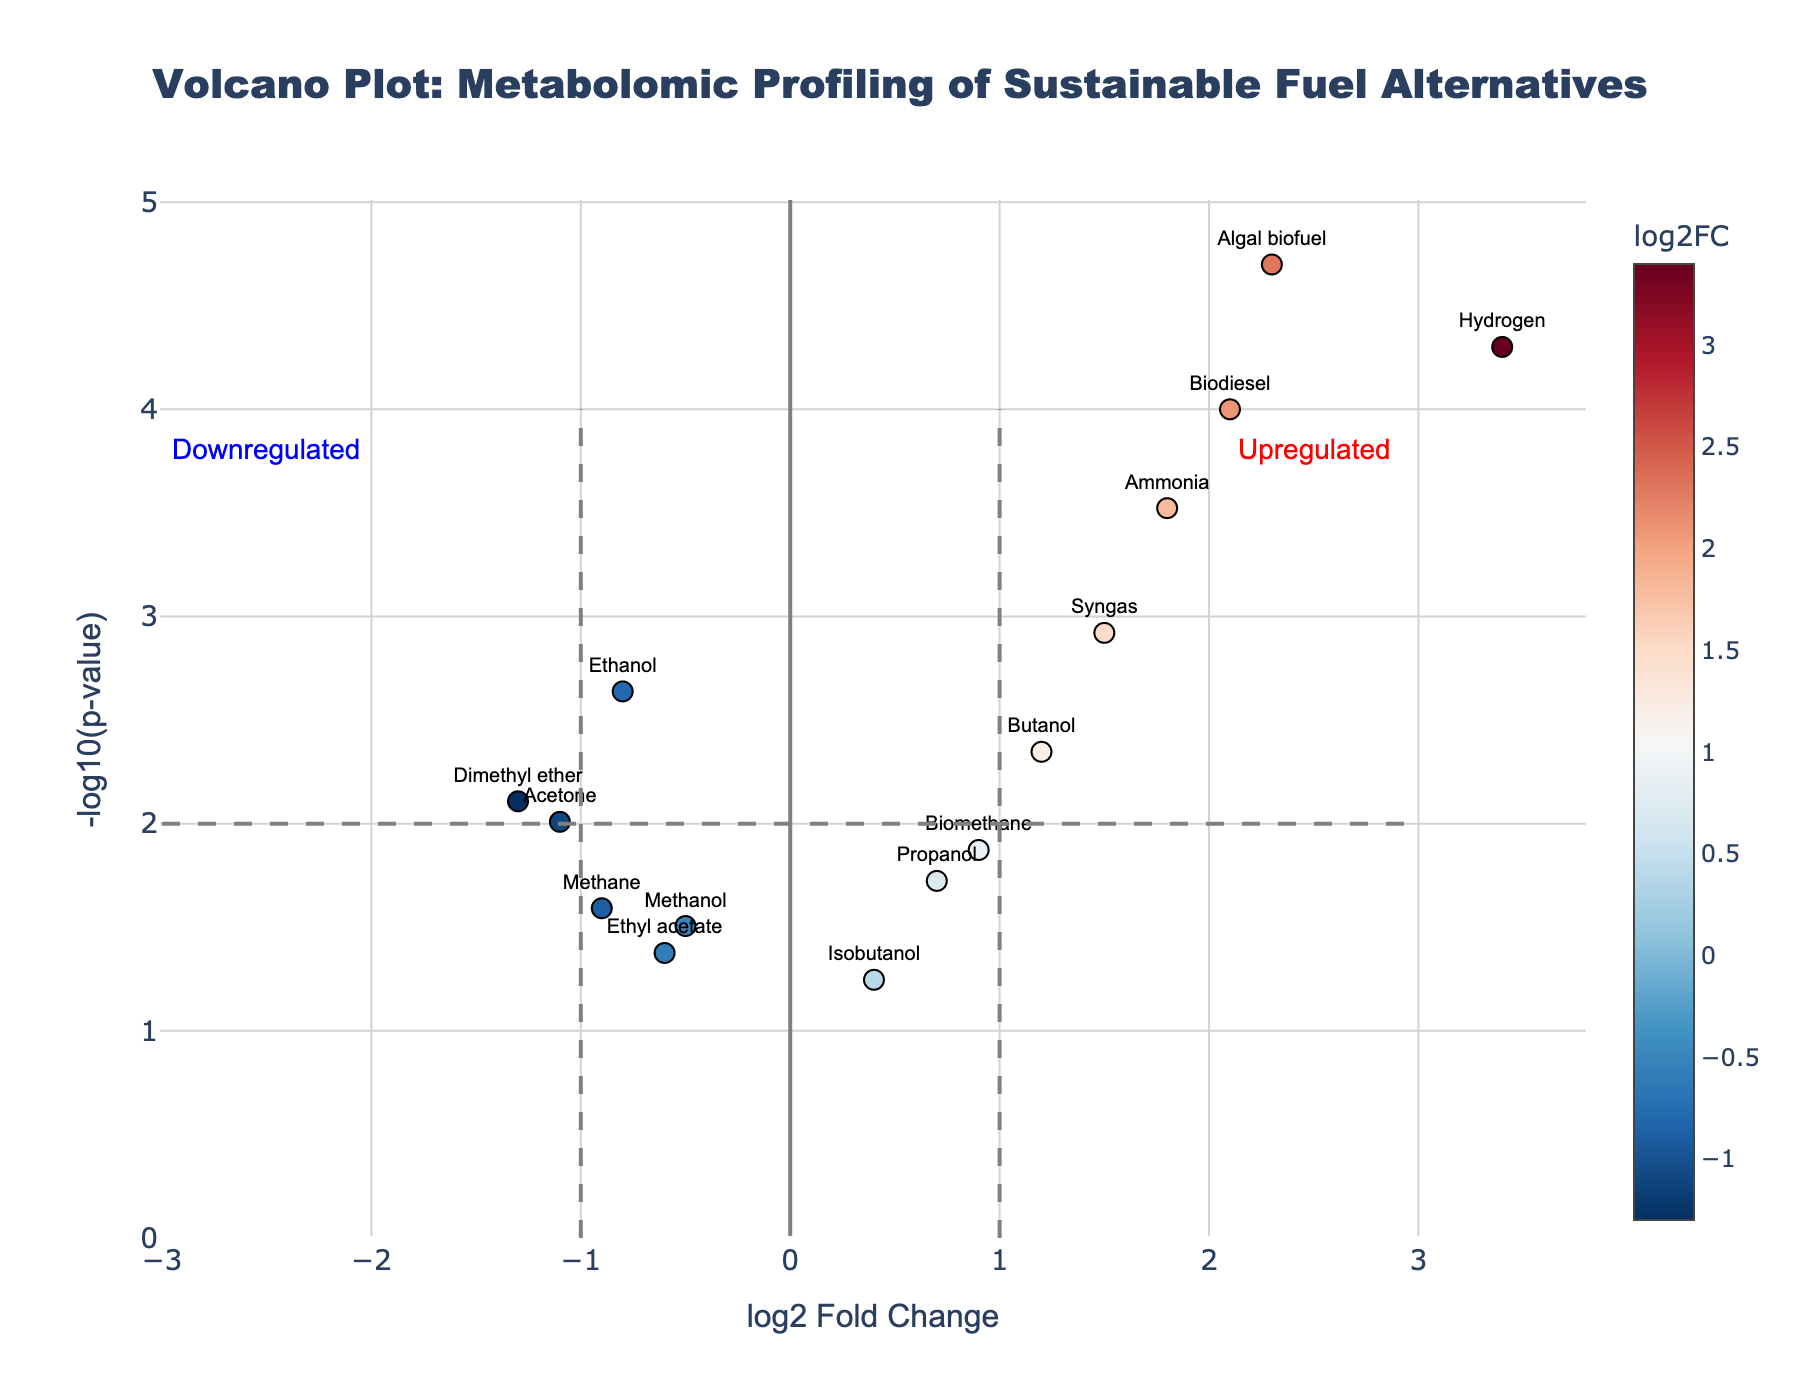How many metabolites are downregulated according to the plot? Downregulated metabolites are those with log2FC < -1 and with significant p-values (typically p < 0.05). From the plot, Ethanol, Methanol, Dimethyl ether, Methane, Ethyl acetate, and Acetone are downregulated based on the log2FC and p-value thresholds.
Answer: 6 Which metabolite has the highest log2 fold change? The highest log2 fold change can be determined by looking at the x-axis for the data point farthest to the right. In this case, Hydrogen is the metabolite with the highest log2FC at 3.4.
Answer: Hydrogen What is the p-value significance threshold implied by the volcano plot? The significance threshold is often represented by a horizontal line in the volcano plot. Here, it is at -log10(p-value) = 2, indicating a p-value threshold of 0.01 (since -log10(0.01) = 2).
Answer: 0.01 How many metabolites have a p-value less than 0.01 and a log2FC greater than 1? To find these data points, locate the plot points above the -log10(p-value) = 2 line and to the right of the log2FC = 1 line. Biodiesel, Hydrogen, Ammonia, Syngas, Biomethane, and Algal biofuel meet these criteria.
Answer: 6 Which metabolite is closest to the origin (0, 0) on the plot? The distance from the origin can be calculated using the Euclidean distance formula √(log2FC^2 + -log10(p-value)^2). Isobutanol, with log2FC = 0.4 and -log10(p-value) approximately 1.25, is closest to the origin.
Answer: Isobutanol What does the color in the scatter plot represent? The color in the scatter plot represents the log2 fold change values of the metabolites.
Answer: log2 fold change Which metabolite shows the most significant p-value? The most significant p-value corresponds to the highest -log10(p-value). Here, Hydrogen shows the most significant p-value with -log10(p-value) = 5.3010.
Answer: Hydrogen Are there any metabolites in the plot that do not reach the significance threshold at p-value < 0.05? Look for metabolites where -log10(p-value) is less than 1.3. Isobutanol, with a -log10(p-value) less than 1.3, does not meet the p-value significance threshold.
Answer: Isobutanol Which region in the plot shows metabolites that are upregulated? Upregulated metabolites have positive log2FC values and are typically found on the right side of the plot.
Answer: Right side 